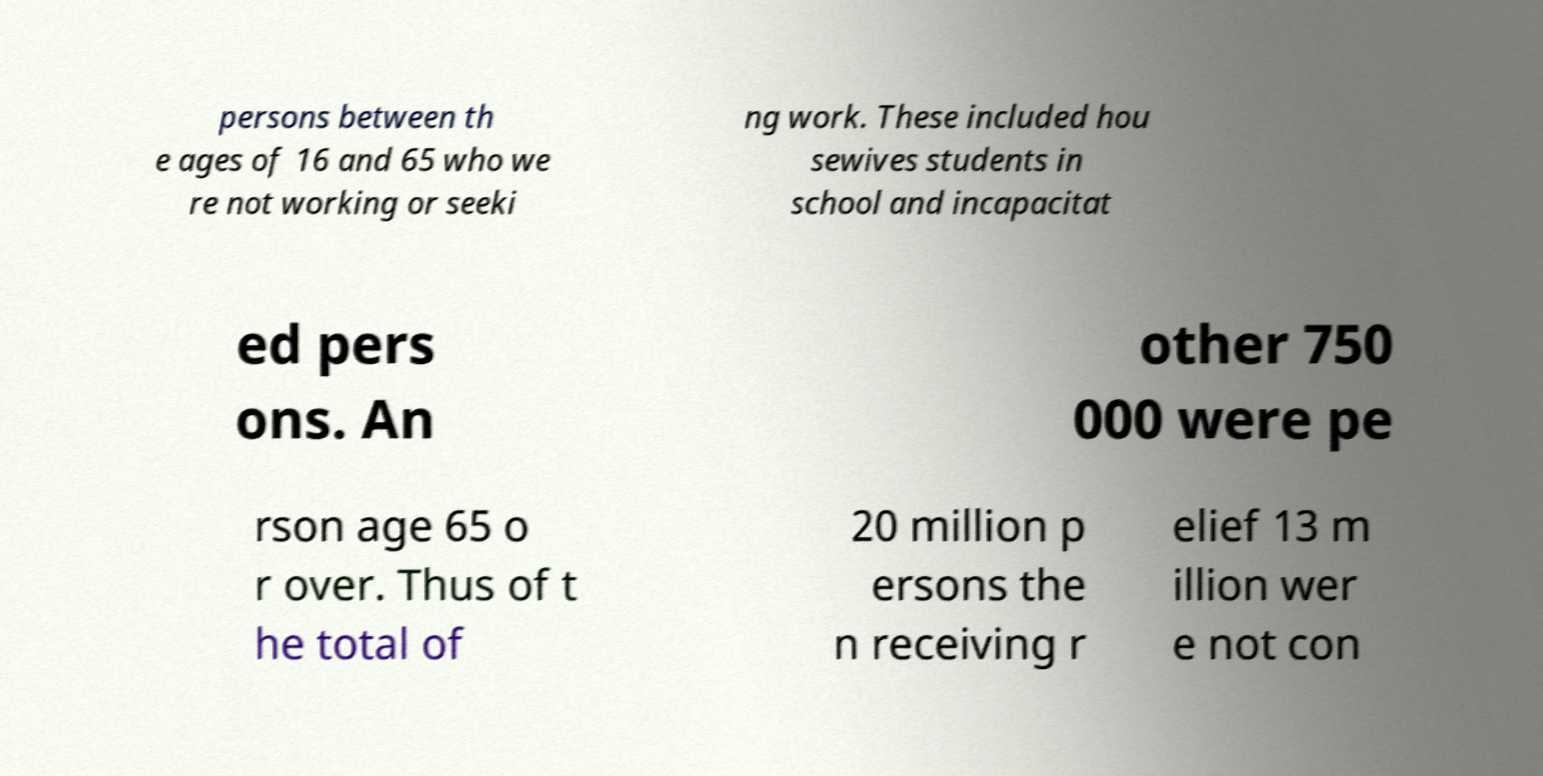Can you read and provide the text displayed in the image?This photo seems to have some interesting text. Can you extract and type it out for me? persons between th e ages of 16 and 65 who we re not working or seeki ng work. These included hou sewives students in school and incapacitat ed pers ons. An other 750 000 were pe rson age 65 o r over. Thus of t he total of 20 million p ersons the n receiving r elief 13 m illion wer e not con 